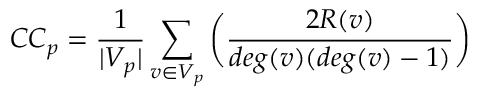<formula> <loc_0><loc_0><loc_500><loc_500>C C _ { p } = \frac { 1 } { | V _ { p } | } \sum _ { v \in V _ { p } } \left ( \frac { 2 R ( v ) } { d e g ( v ) ( d e g ( v ) - 1 ) } \right )</formula> 